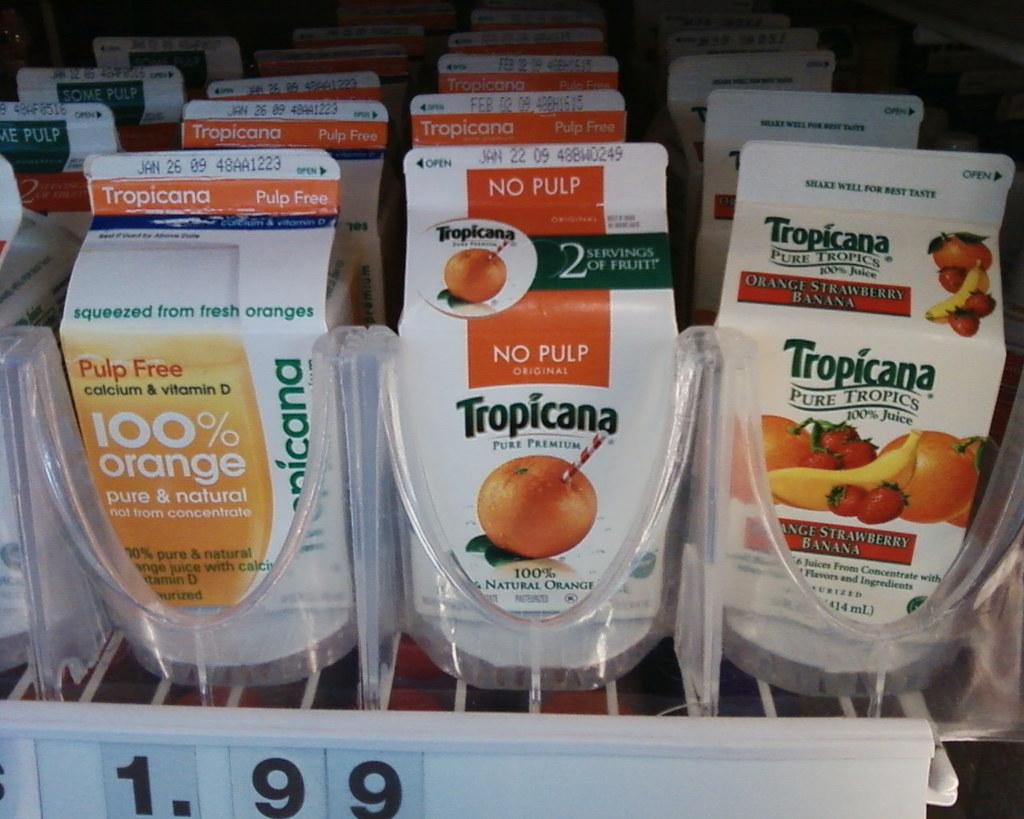What type of product is displayed in the image? There are Tropicana juice cartons in the image. How are the juice cartons arranged in the image? The juice cartons are in a display. Is there any additional information about the displayed products? Yes, there is a price card associated with the display. What type of wound can be seen on the juice cartons in the image? There are no wounds visible on the juice cartons in the image. What type of vessel is used to store the juice in the image? The image does not show the actual juice storage; it only displays the Tropicana juice cartons. 